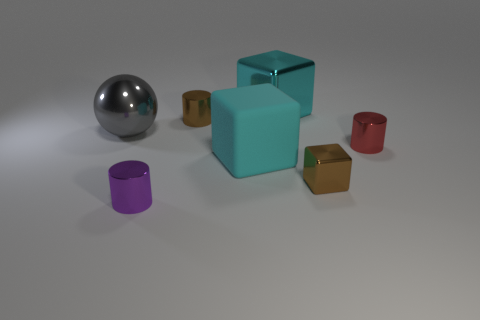Subtract all large cyan blocks. How many blocks are left? 1 Subtract all red cylinders. How many cylinders are left? 2 Subtract all cubes. How many objects are left? 4 Subtract 1 cubes. How many cubes are left? 2 Add 3 large red blocks. How many objects exist? 10 Subtract all green spheres. Subtract all red cubes. How many spheres are left? 1 Subtract all green spheres. How many purple cylinders are left? 1 Subtract all small shiny things. Subtract all brown metallic cylinders. How many objects are left? 2 Add 6 tiny purple cylinders. How many tiny purple cylinders are left? 7 Add 6 gray spheres. How many gray spheres exist? 7 